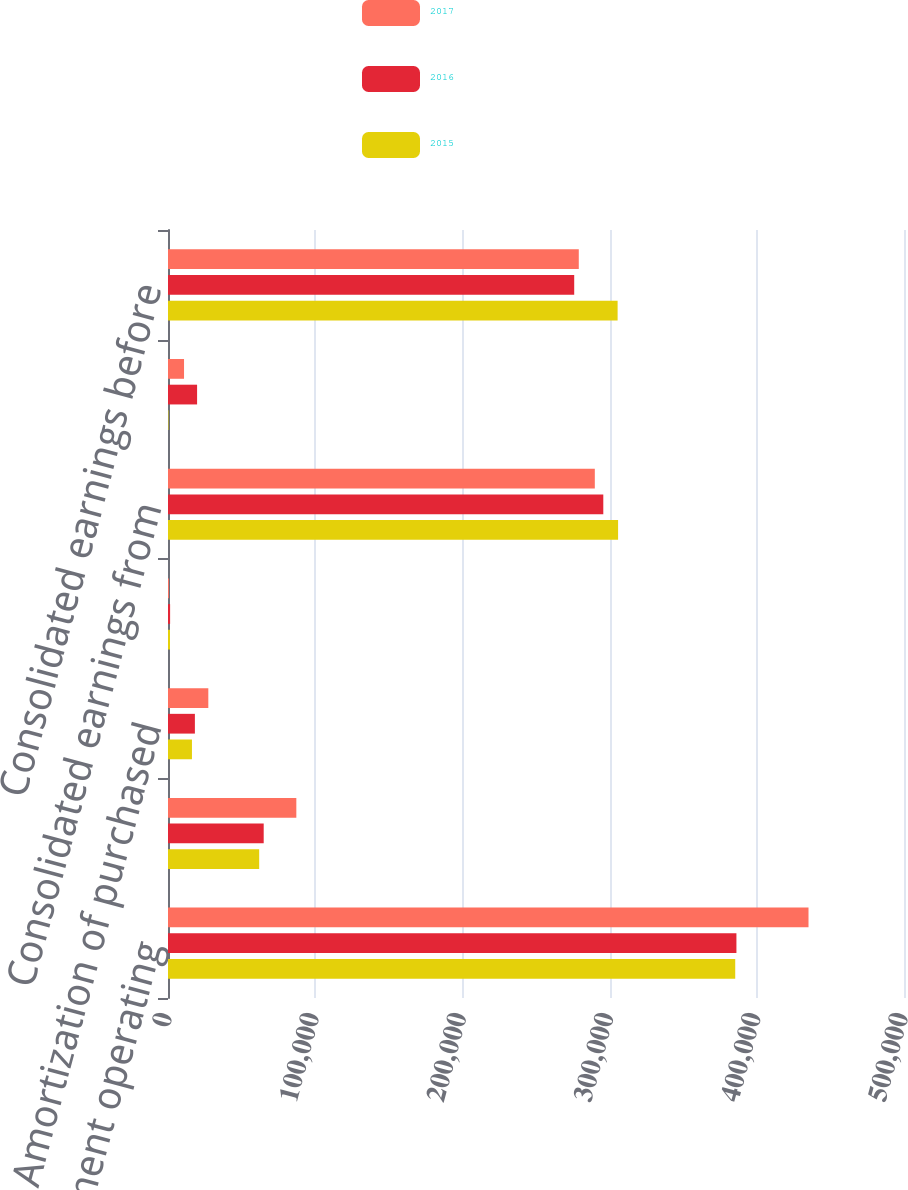Convert chart. <chart><loc_0><loc_0><loc_500><loc_500><stacked_bar_chart><ecel><fcel>Consolidated segment operating<fcel>Unallocated corporate expenses<fcel>Amortization of purchased<fcel>Restructuring charges<fcel>Consolidated earnings from<fcel>Interest and non-operating<fcel>Consolidated earnings before<nl><fcel>2017<fcel>435129<fcel>87184<fcel>27391<fcel>625<fcel>289961<fcel>10896<fcel>279065<nl><fcel>2016<fcel>386157<fcel>65012<fcel>18266<fcel>1431<fcel>295718<fcel>19761<fcel>275957<nl><fcel>2015<fcel>385346<fcel>61946<fcel>16275<fcel>1361<fcel>305764<fcel>318<fcel>305446<nl></chart> 